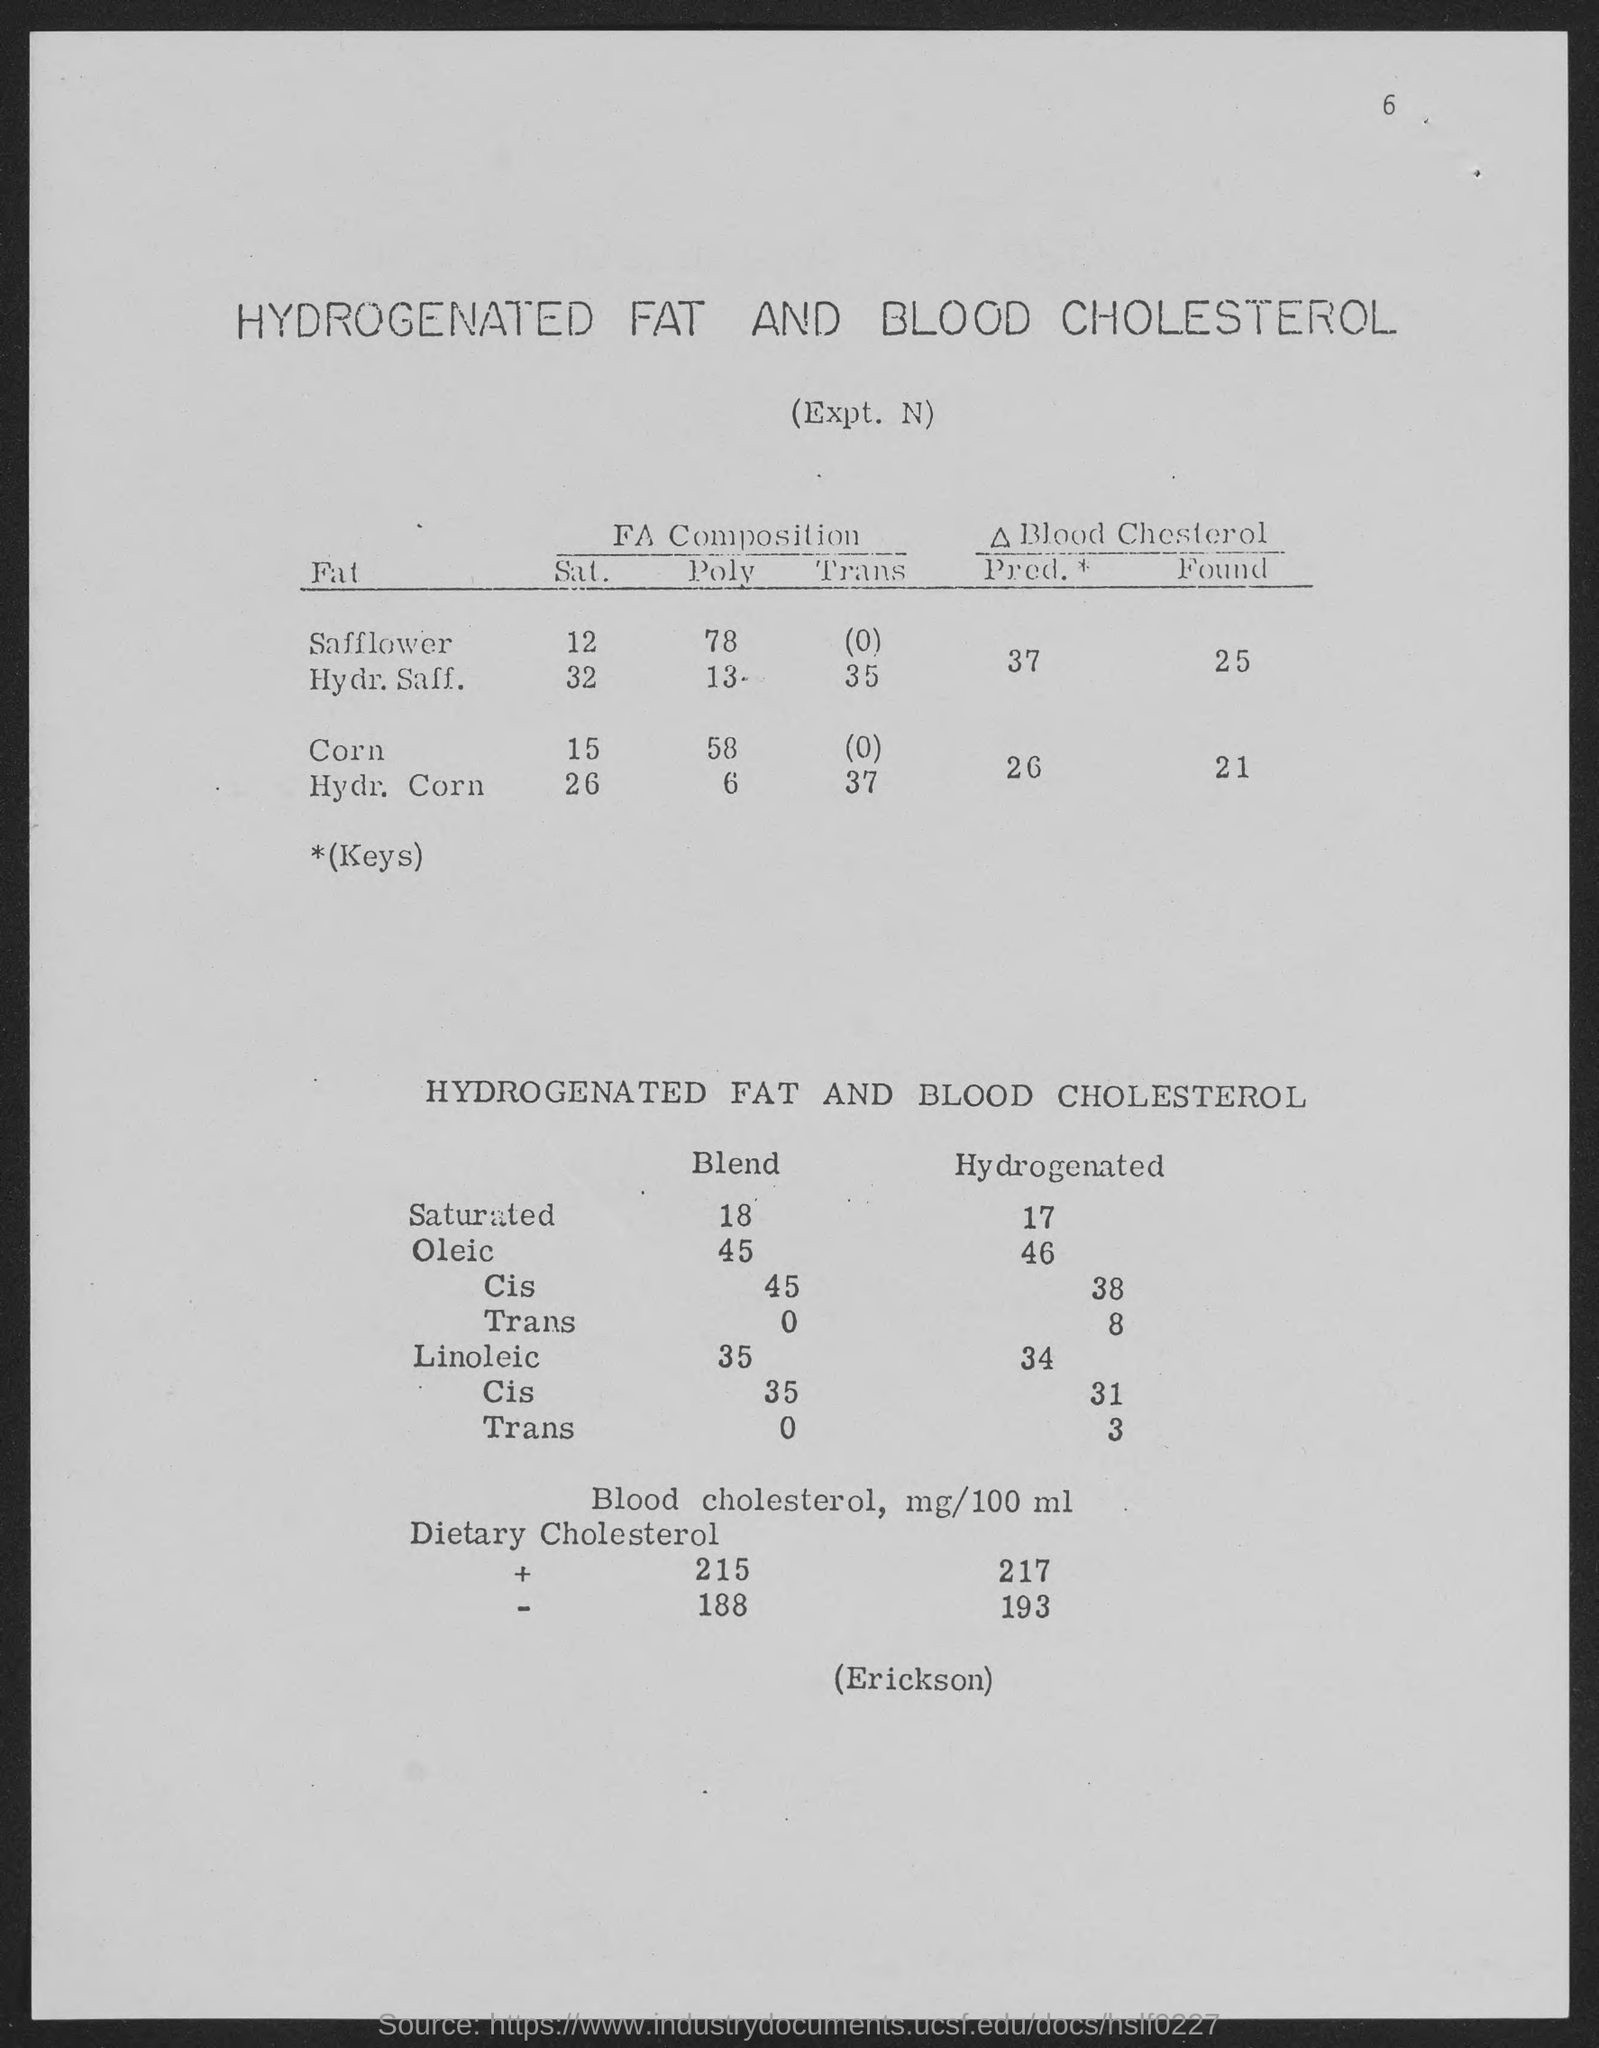What is the number at top-right corner of the page?
Your response must be concise. 6. 